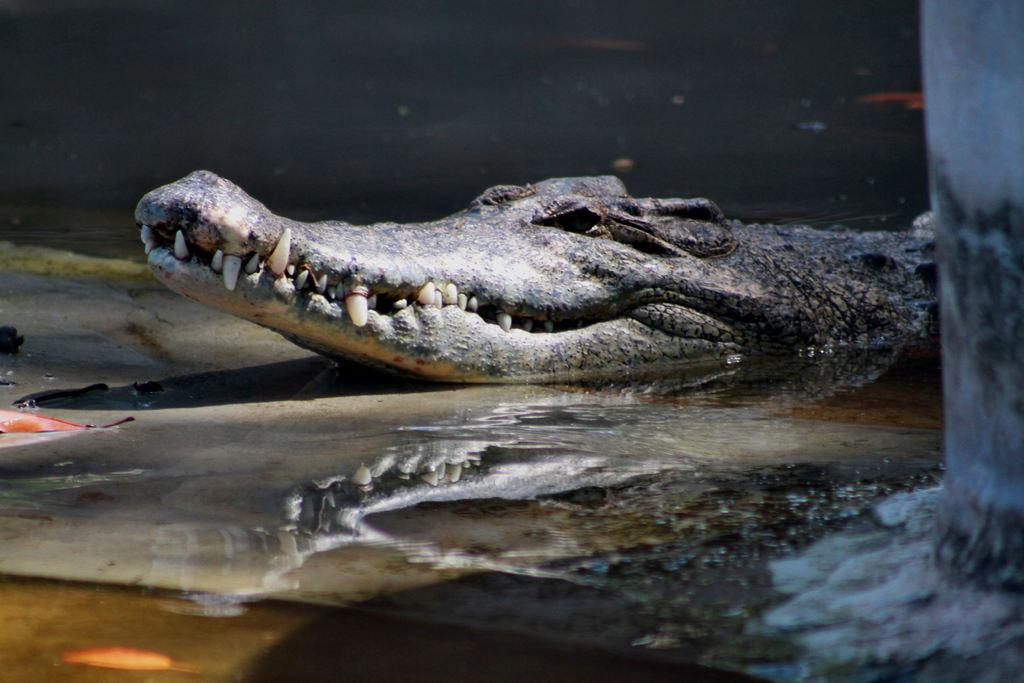What animal is present in the image? There is a crocodile in the image. Where is the crocodile located? The crocodile is in the water. What type of desk can be seen in the image? There is no desk present in the image; it features a crocodile in the water. Is the queen visible in the image? There is no queen present in the image; it features a crocodile in the water. 